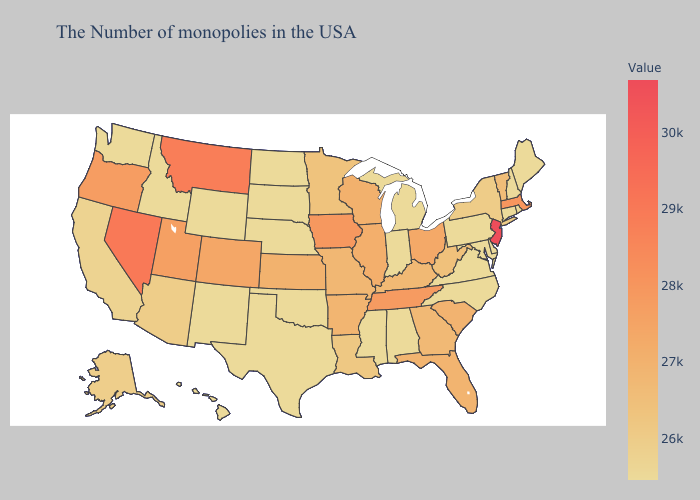Does Alaska have the lowest value in the USA?
Short answer required. No. Does Montana have the highest value in the USA?
Give a very brief answer. No. Does New Jersey have the highest value in the USA?
Concise answer only. Yes. Does West Virginia have a lower value than Wyoming?
Answer briefly. No. Among the states that border Ohio , which have the highest value?
Short answer required. Kentucky. Does New Jersey have the highest value in the USA?
Write a very short answer. Yes. Among the states that border Texas , which have the lowest value?
Give a very brief answer. Oklahoma, New Mexico. Which states have the lowest value in the USA?
Concise answer only. Maine, Rhode Island, New Hampshire, Connecticut, Delaware, Maryland, Pennsylvania, Virginia, North Carolina, Michigan, Indiana, Alabama, Mississippi, Nebraska, Oklahoma, Texas, South Dakota, North Dakota, Wyoming, New Mexico, Idaho, Washington, Hawaii. 